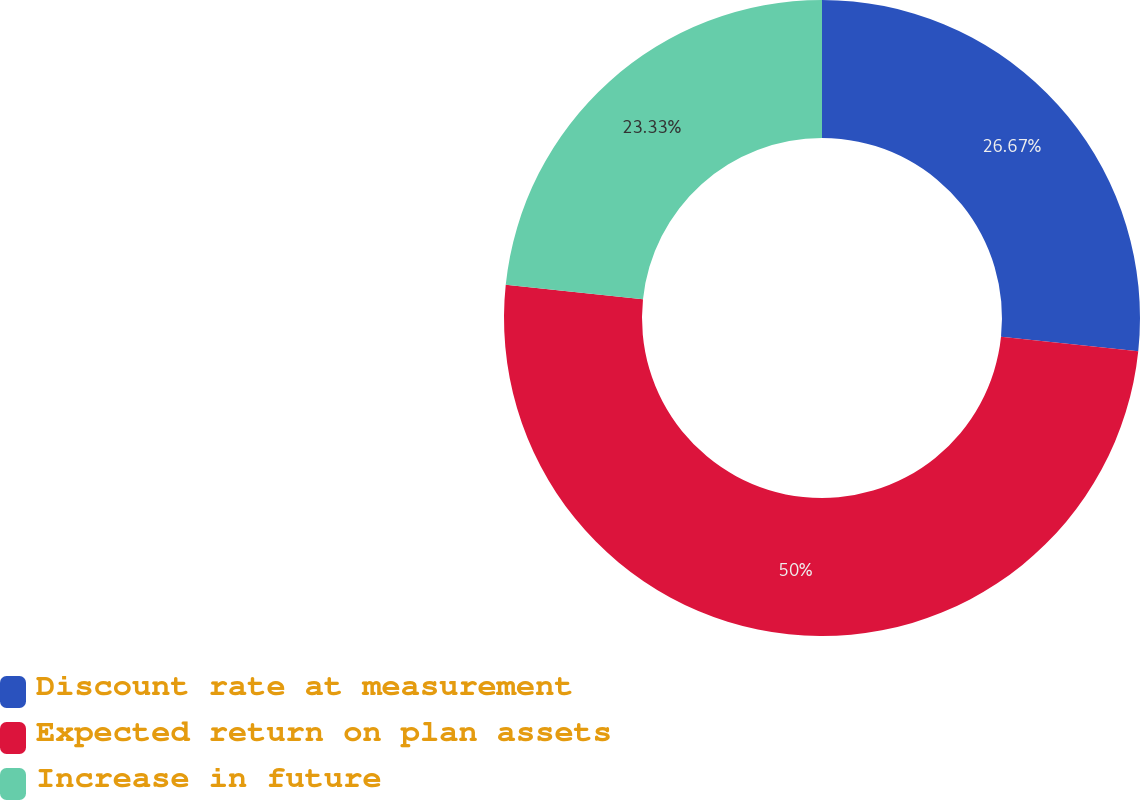<chart> <loc_0><loc_0><loc_500><loc_500><pie_chart><fcel>Discount rate at measurement<fcel>Expected return on plan assets<fcel>Increase in future<nl><fcel>26.67%<fcel>50.0%<fcel>23.33%<nl></chart> 